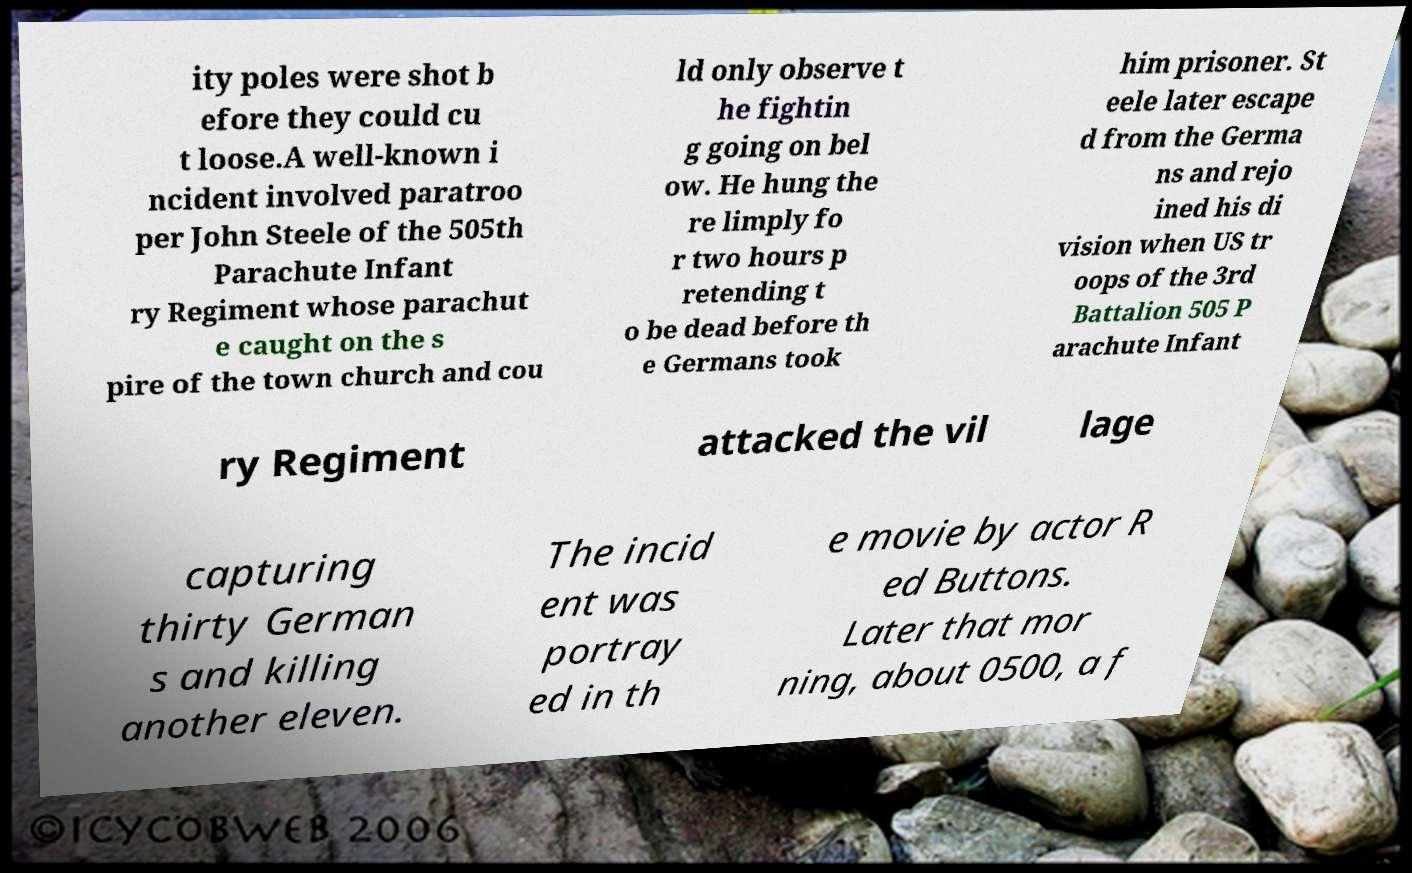Could you assist in decoding the text presented in this image and type it out clearly? ity poles were shot b efore they could cu t loose.A well-known i ncident involved paratroo per John Steele of the 505th Parachute Infant ry Regiment whose parachut e caught on the s pire of the town church and cou ld only observe t he fightin g going on bel ow. He hung the re limply fo r two hours p retending t o be dead before th e Germans took him prisoner. St eele later escape d from the Germa ns and rejo ined his di vision when US tr oops of the 3rd Battalion 505 P arachute Infant ry Regiment attacked the vil lage capturing thirty German s and killing another eleven. The incid ent was portray ed in th e movie by actor R ed Buttons. Later that mor ning, about 0500, a f 